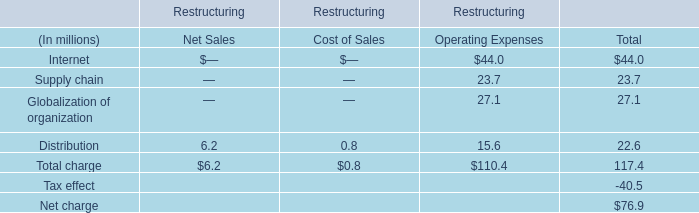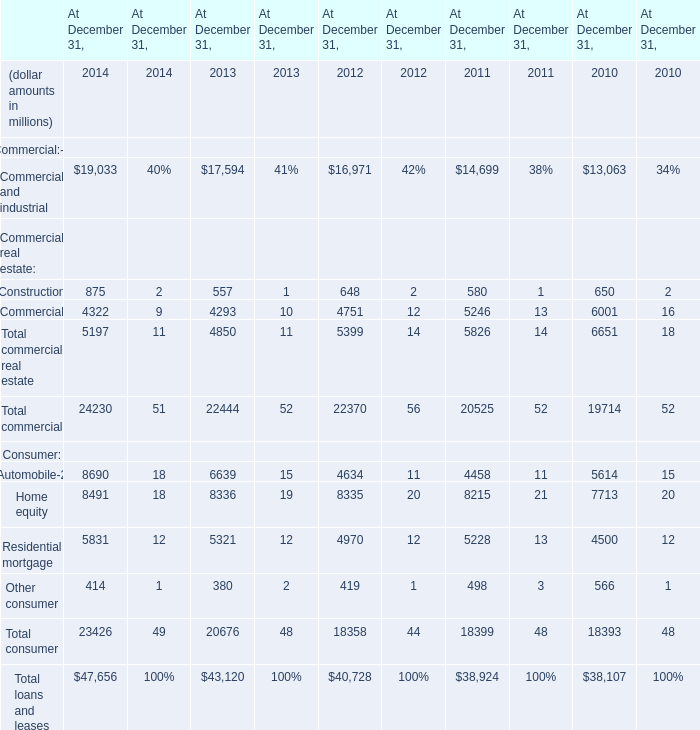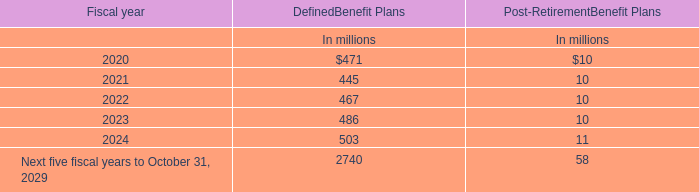What is the growing rate of Total commercial in the year with the most Commercial? 
Computations: ((20525 - 19714) / 19714)
Answer: 0.04114. 